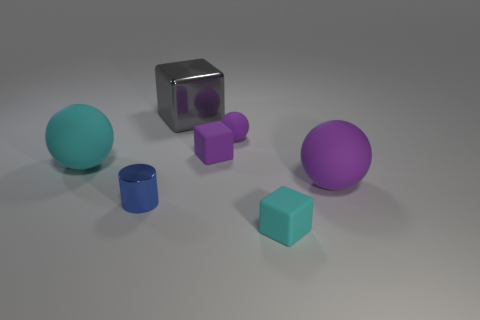Subtract all purple cubes. Subtract all gray cylinders. How many cubes are left? 2 Add 1 small objects. How many objects exist? 8 Subtract all cylinders. How many objects are left? 6 Subtract 0 cyan cylinders. How many objects are left? 7 Subtract all small red metal objects. Subtract all tiny purple cubes. How many objects are left? 6 Add 7 tiny purple rubber balls. How many tiny purple rubber balls are left? 8 Add 2 purple things. How many purple things exist? 5 